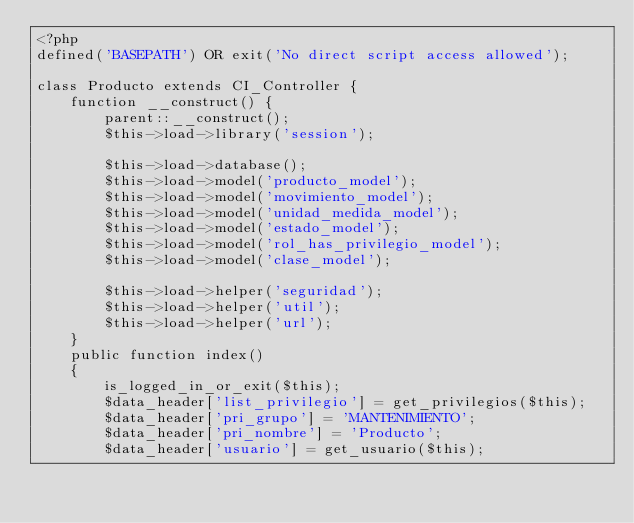Convert code to text. <code><loc_0><loc_0><loc_500><loc_500><_PHP_><?php
defined('BASEPATH') OR exit('No direct script access allowed');

class Producto extends CI_Controller {
	function __construct() {
		parent::__construct();
		$this->load->library('session');
		
		$this->load->database();
		$this->load->model('producto_model');
		$this->load->model('movimiento_model');
		$this->load->model('unidad_medida_model');
		$this->load->model('estado_model');
		$this->load->model('rol_has_privilegio_model');
		$this->load->model('clase_model');
		
		$this->load->helper('seguridad');
		$this->load->helper('util');
		$this->load->helper('url');
	}
	public function index()
	{
		is_logged_in_or_exit($this);
		$data_header['list_privilegio'] = get_privilegios($this);
		$data_header['pri_grupo'] = 'MANTENIMIENTO';
		$data_header['pri_nombre'] = 'Producto';
		$data_header['usuario'] = get_usuario($this);</code> 